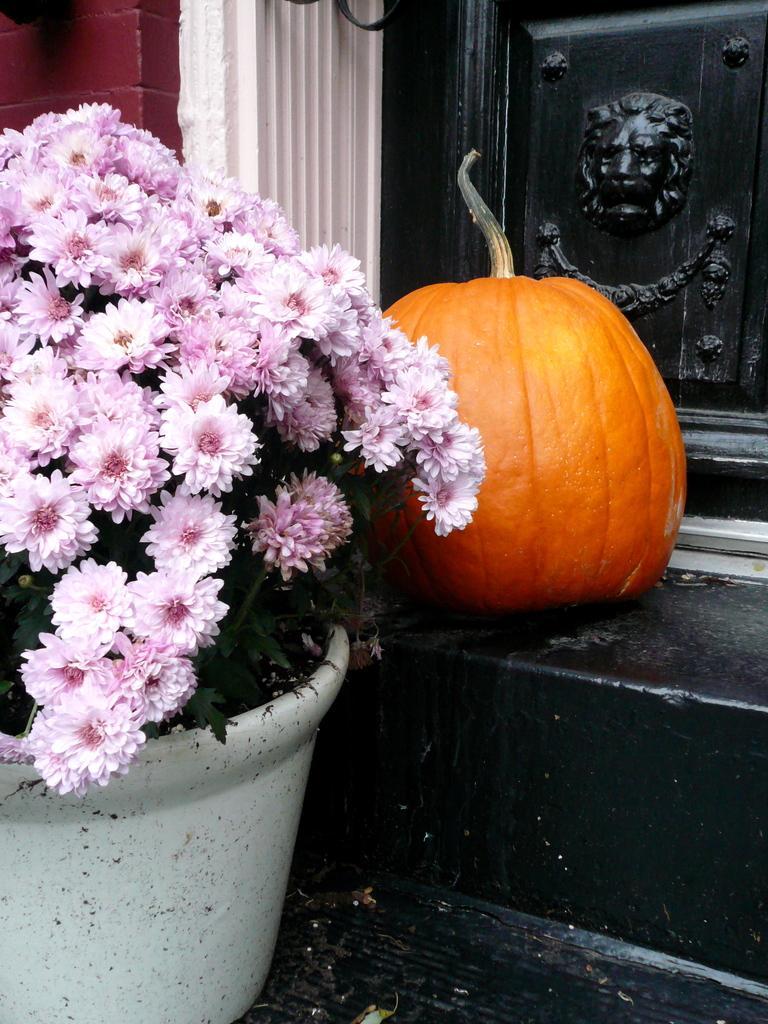Describe this image in one or two sentences. In this picture, we can see the wall with door, we can see stairs, and some objects on the stair like plant with flowers in a pot, pumpkin. 